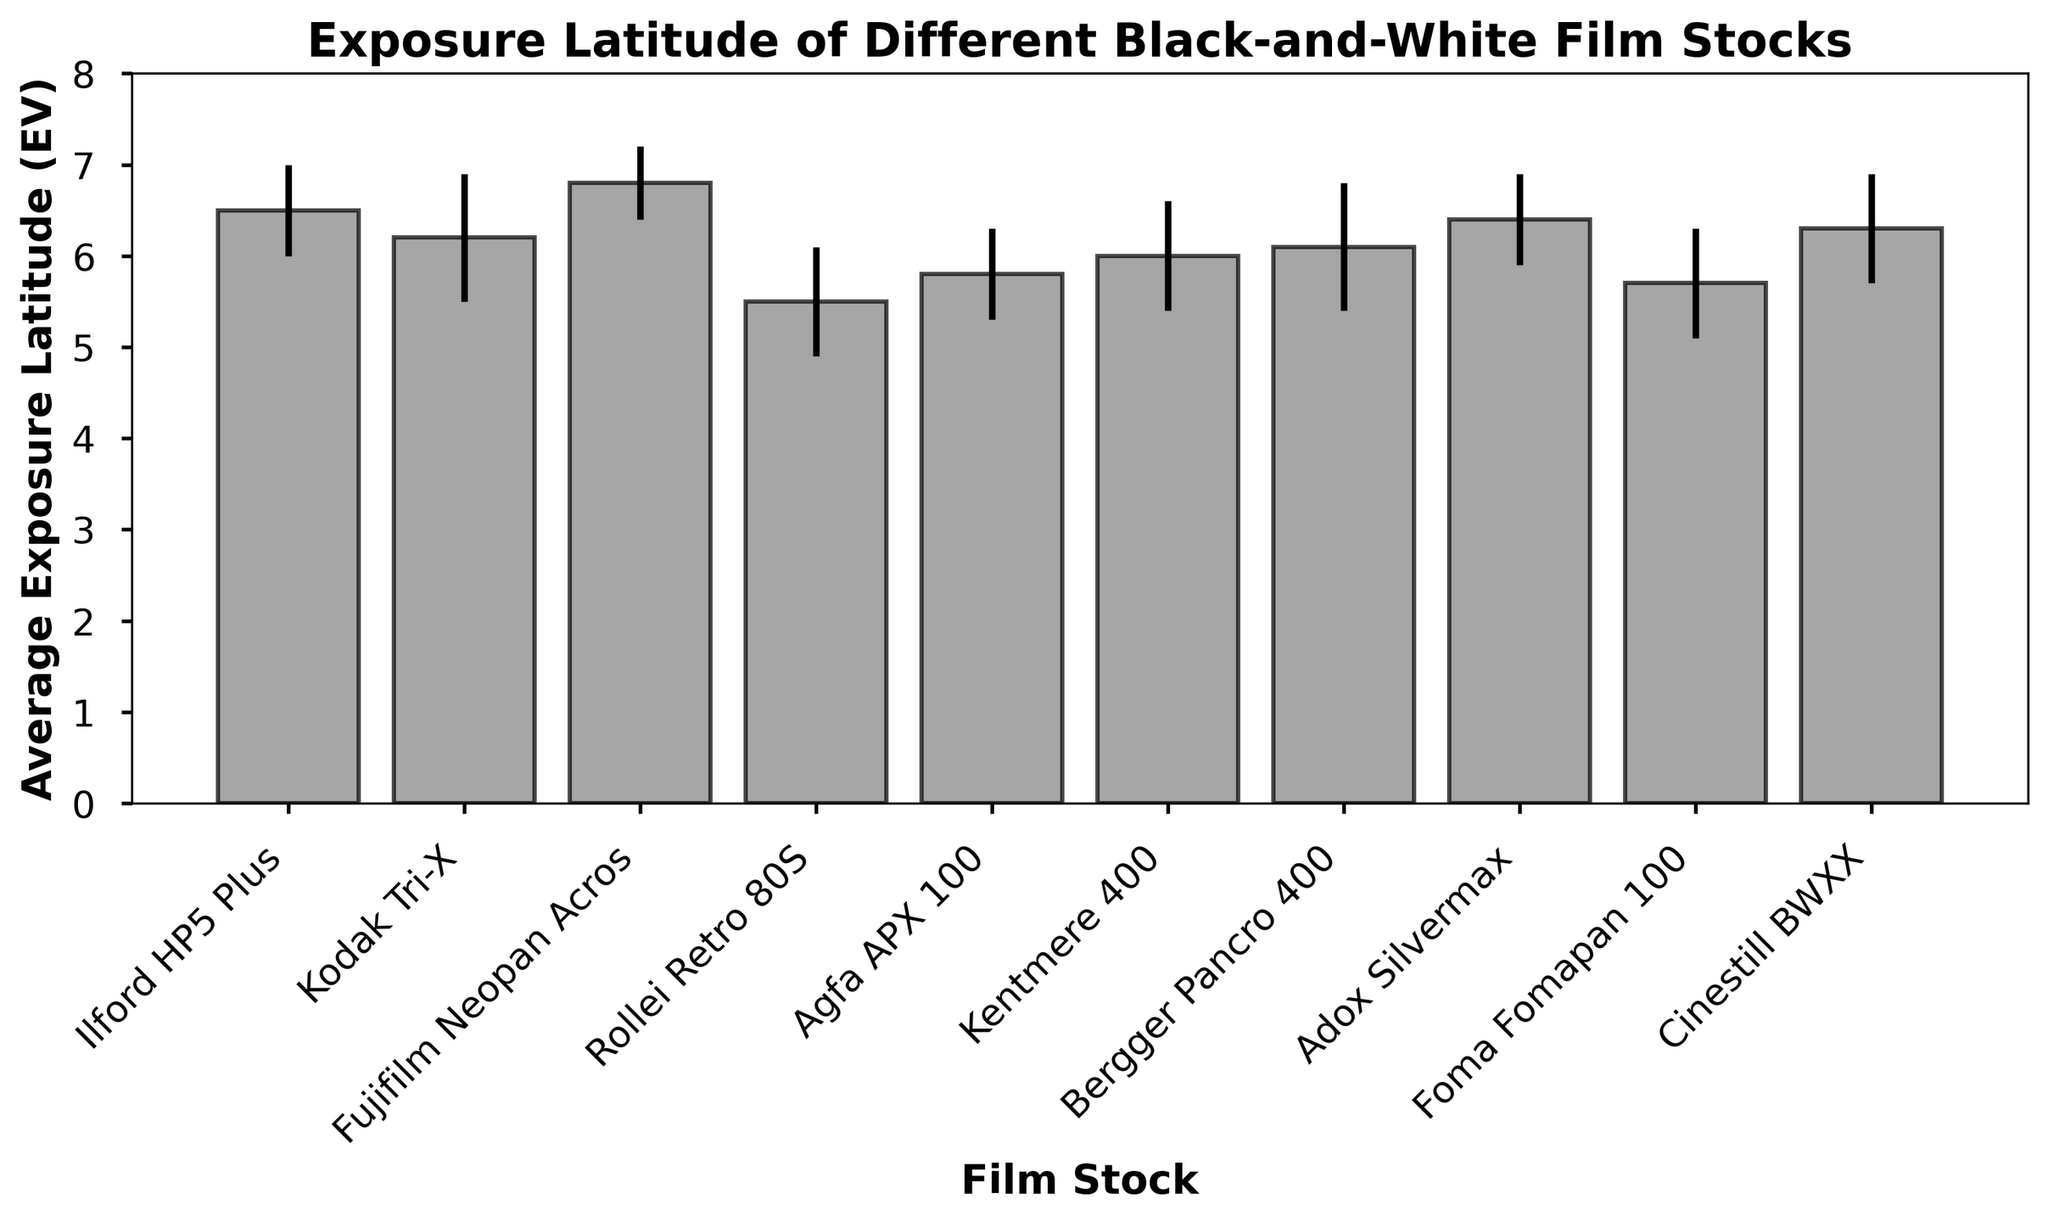What is the film stock with the highest average exposure latitude? To find the film stock with the highest average exposure latitude, we look at the bar chart and identify the tallest bar. The tallest bar corresponds to Fujifilm Neopan Acros.
Answer: Fujifilm Neopan Acros Which film stock has the lowest average exposure latitude? By observing the bar chart, we identify the shortest bar to determine the film stock with the lowest average exposure latitude. The shortest bar corresponds to Rollei Retro 80S.
Answer: Rollei Retro 80S How much greater is the average exposure latitude of Fujifilm Neopan Acros compared to Rollei Retro 80S? First, we note the average exposure latitude values: Fujifilm Neopan Acros has 6.8 EV and Rollei Retro 80S has 5.5 EV. The difference is calculated as 6.8 - 5.5 = 1.3 EV.
Answer: 1.3 EV Which two film stocks have the closest average exposure latitude? By comparing the average exposure latitude values visually, we see that Bergger Pancro 400 (6.1 EV) and Kentmere 400 (6.0 EV) have the closest values.
Answer: Bergger Pancro 400 and Kentmere 400 What is the average exposure latitude for all listed film stocks? To calculate this, we sum the average exposure latitudes and then divide by the number of film stocks. The sum is 6.5 + 6.2 + 6.8 + 5.5 + 5.8 + 6.0 + 6.1 + 6.4 + 5.7 + 6.3 = 61.3. There are 10 film stocks, so the average is 61.3/10 = 6.13 EV.
Answer: 6.13 EV Which film stock has the largest variation in exposure latitude under different lighting conditions? Variation in exposure latitude is indicated by the size of the error bars. The largest error bar corresponds to Kodak Tri-X with a standard deviation of 0.7 EV.
Answer: Kodak Tri-X How does Ilford HP5 Plus compare to Kodak Tri-X in terms of average exposure latitude and standard deviation? Ilford HP5 Plus has an average exposure latitude of 6.5 EV and a standard deviation of 0.5 EV. Kodak Tri-X has an average latitude of 6.2 EV and a standard deviation of 0.7 EV. Ilford HP5 Plus has a higher average but lower variation than Kodak Tri-X.
Answer: Ilford HP5 Plus has a higher average and lower variation Which film stock has an average exposure latitude closest to 6.0 EV? Visually scanning for a bar with an average exposure latitude close to 6.0 EV, we find that Kentmere 400 fits this category with an exact value of 6.0 EV.
Answer: Kentmere 400 